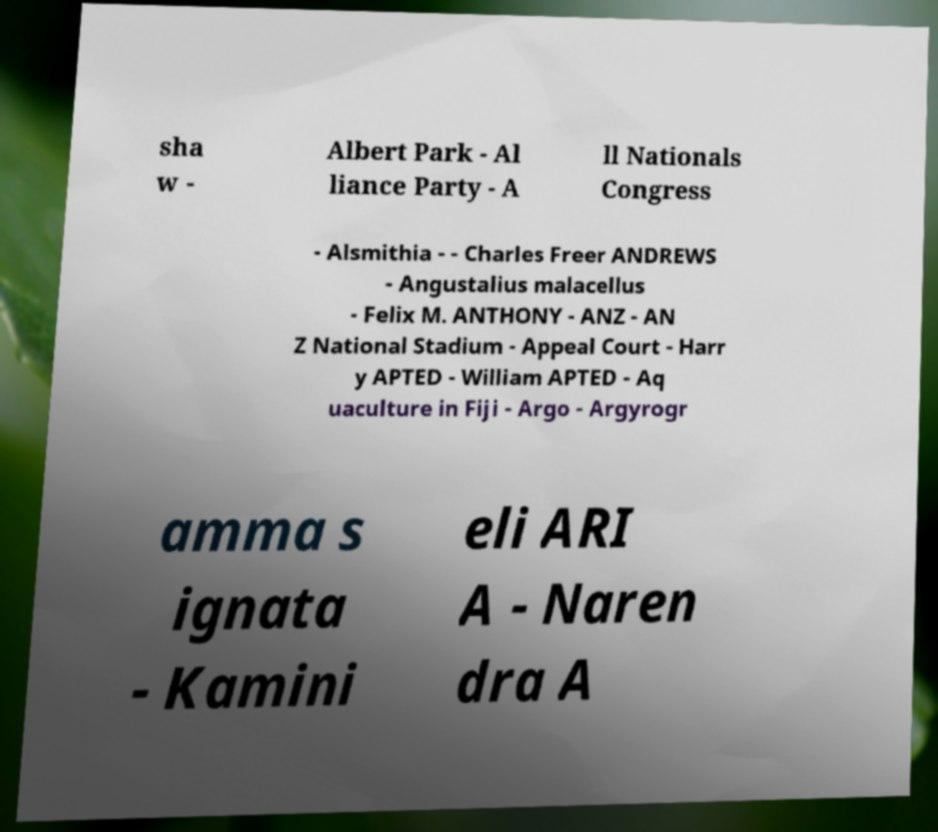Can you accurately transcribe the text from the provided image for me? sha w - Albert Park - Al liance Party - A ll Nationals Congress - Alsmithia - - Charles Freer ANDREWS - Angustalius malacellus - Felix M. ANTHONY - ANZ - AN Z National Stadium - Appeal Court - Harr y APTED - William APTED - Aq uaculture in Fiji - Argo - Argyrogr amma s ignata - Kamini eli ARI A - Naren dra A 